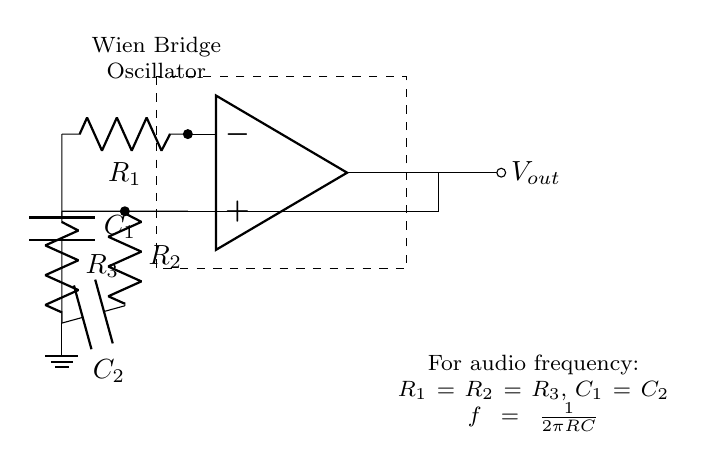What is the type of oscillator depicted? The circuit diagram illustrates a Wien Bridge Oscillator, which is specifically designed for generating low-distortion sine waves. This is indicated by the title within the schematic and the specific arrangement of components that permit sine wave generation.
Answer: Wien Bridge Oscillator How many resistors are in the circuit? In the provided circuit diagram, there are three resistors: R1, R2, and R3. The diagram denotes these resistors, and we can count them visually in the circuit layout.
Answer: Three What is the purpose of the capacitor in this circuit? The capacitors C1 and C2 in the Wien Bridge Oscillator are crucial for determining the frequency of oscillation and ensuring stability in the signal generation. Their placement in the feedback and phase-shift sections help establish the necessary conditions for sustained oscillations.
Answer: Frequency determination What is the relationship between the resistances and capacitances used for audio frequency? The circuit notes that for audio frequency oscillations, R1 equals R2 equals R3, and C1 equals C2, leading to the formula f = 1/(2πRC). This means that the frequency produced is directly tied to these equal values of resistance and capacitance, allowing for predictable frequency output within audio ranges.
Answer: R1 = R2 = R3, C1 = C2 What does the output voltage represent in this circuit? The output voltage, denoted as Vout, represents the generated sine wave signal from the oscillator. This is critical in audio applications, where low-distortion sine waves are required for sound reproduction or other purposes. Its position in the diagram indicates it is the final output of the oscillator circuit.
Answer: Generated sine wave What is the significance of the ground connection in the circuit? The ground connection in the circuit provides a reference point for voltages within the circuit. It ensures stable operation by establishing a common return path for current, which is fundamental in all electronic circuits, including oscillators like this one. This helps in maintaining consistent performance by minimizing noise and signal fluctuations.
Answer: Reference point What is the formula for the output frequency in this circuit? The diagram specifies the formula f = 1/(2πRC) for determining the output frequency of the oscillator, highlighting the direct relationship between frequency (f), resistance (R), and capacitance (C). This information reflects the design's emphasis on generating specific frequencies based on chosen values for R and C.
Answer: f = 1/(2πRC) 